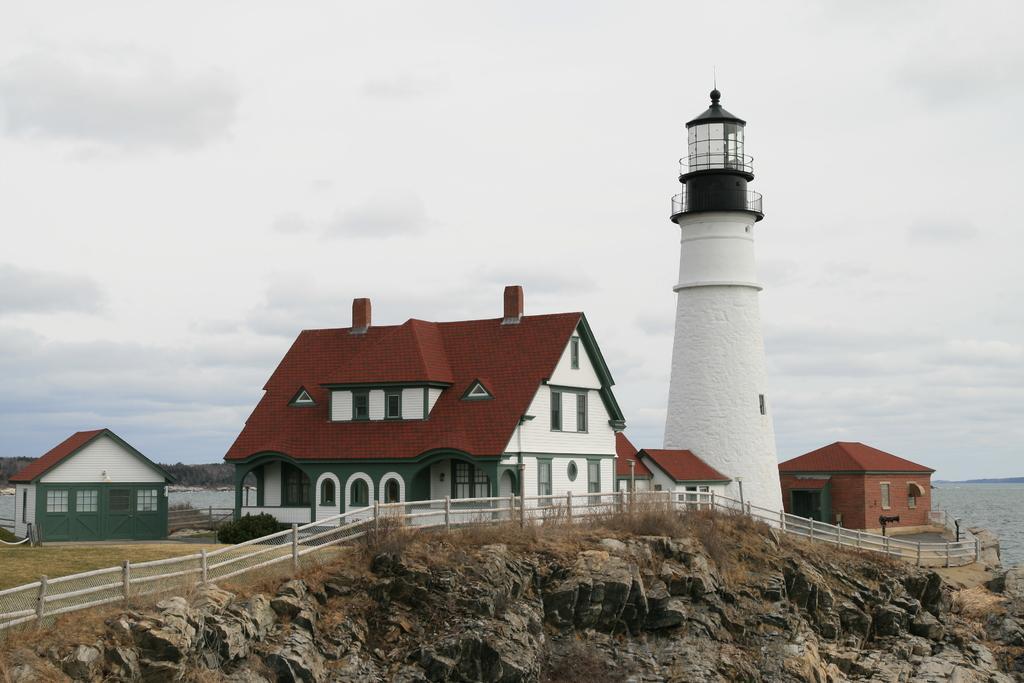How would you summarize this image in a sentence or two? In this image, I can see the houses, fence, plants and a lighthouse on a hill. On the right side of the image, there is water. In the background, I can see the sky. 